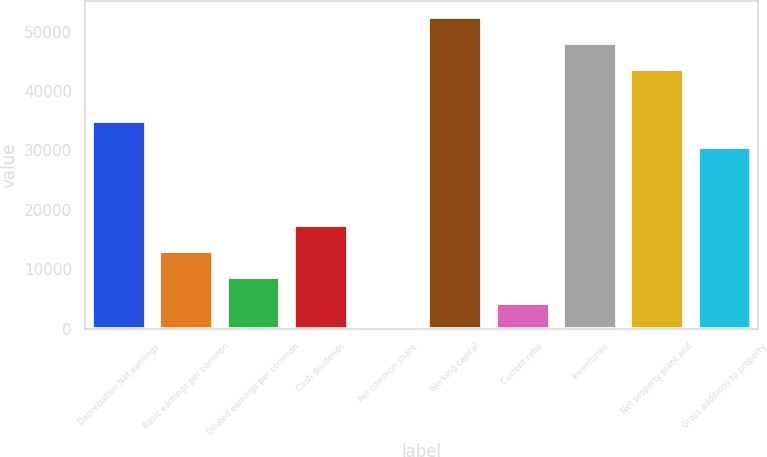Convert chart. <chart><loc_0><loc_0><loc_500><loc_500><bar_chart><fcel>Depreciation Net earnings<fcel>Basic earnings per common<fcel>Diluted earnings per common<fcel>Cash dividends<fcel>Per common share<fcel>Working capital<fcel>Current ratio<fcel>Inventories<fcel>Net property plant and<fcel>Gross additions to property<nl><fcel>35001.7<fcel>13126.1<fcel>8751<fcel>17501.2<fcel>0.76<fcel>52502.2<fcel>4375.88<fcel>48127.1<fcel>43752<fcel>30626.6<nl></chart> 